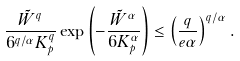<formula> <loc_0><loc_0><loc_500><loc_500>\frac { \tilde { W } ^ { q } } { 6 ^ { q / \alpha } K _ { p } ^ { q } } \exp \left ( - \frac { \tilde { W } ^ { \alpha } } { 6 K _ { p } ^ { \alpha } } \right ) \leq \left ( \frac { q } { e \alpha } \right ) ^ { q / \alpha } .</formula> 